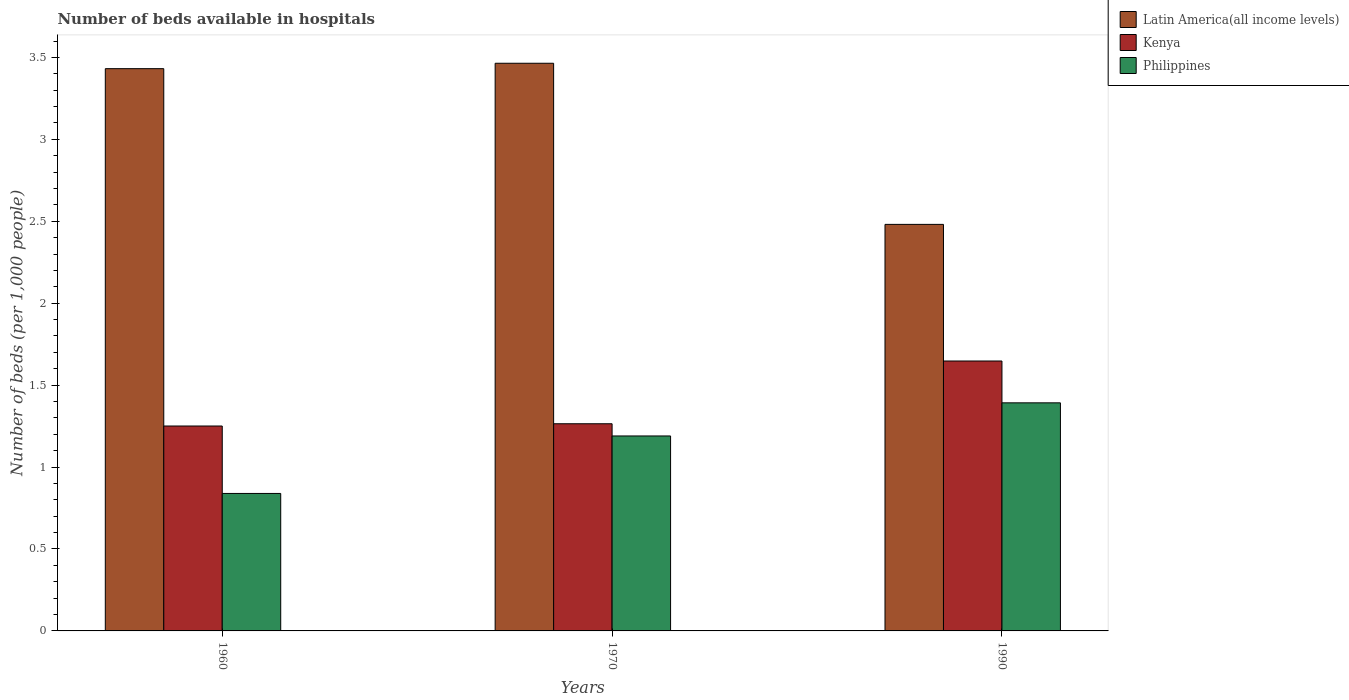How many different coloured bars are there?
Ensure brevity in your answer.  3. Are the number of bars on each tick of the X-axis equal?
Ensure brevity in your answer.  Yes. How many bars are there on the 2nd tick from the left?
Offer a very short reply. 3. How many bars are there on the 1st tick from the right?
Ensure brevity in your answer.  3. In how many cases, is the number of bars for a given year not equal to the number of legend labels?
Offer a terse response. 0. What is the number of beds in the hospiatls of in Latin America(all income levels) in 1990?
Offer a very short reply. 2.48. Across all years, what is the maximum number of beds in the hospiatls of in Latin America(all income levels)?
Your response must be concise. 3.46. Across all years, what is the minimum number of beds in the hospiatls of in Philippines?
Give a very brief answer. 0.84. In which year was the number of beds in the hospiatls of in Latin America(all income levels) minimum?
Keep it short and to the point. 1990. What is the total number of beds in the hospiatls of in Philippines in the graph?
Your answer should be compact. 3.42. What is the difference between the number of beds in the hospiatls of in Philippines in 1960 and that in 1990?
Keep it short and to the point. -0.55. What is the difference between the number of beds in the hospiatls of in Kenya in 1970 and the number of beds in the hospiatls of in Philippines in 1990?
Offer a terse response. -0.13. What is the average number of beds in the hospiatls of in Kenya per year?
Keep it short and to the point. 1.39. In the year 1990, what is the difference between the number of beds in the hospiatls of in Philippines and number of beds in the hospiatls of in Latin America(all income levels)?
Give a very brief answer. -1.09. What is the ratio of the number of beds in the hospiatls of in Philippines in 1960 to that in 1970?
Your answer should be very brief. 0.71. Is the difference between the number of beds in the hospiatls of in Philippines in 1960 and 1970 greater than the difference between the number of beds in the hospiatls of in Latin America(all income levels) in 1960 and 1970?
Your answer should be very brief. No. What is the difference between the highest and the second highest number of beds in the hospiatls of in Philippines?
Provide a short and direct response. 0.2. What is the difference between the highest and the lowest number of beds in the hospiatls of in Latin America(all income levels)?
Your answer should be very brief. 0.98. In how many years, is the number of beds in the hospiatls of in Kenya greater than the average number of beds in the hospiatls of in Kenya taken over all years?
Ensure brevity in your answer.  1. What does the 2nd bar from the left in 1990 represents?
Your answer should be very brief. Kenya. What does the 1st bar from the right in 1960 represents?
Give a very brief answer. Philippines. Is it the case that in every year, the sum of the number of beds in the hospiatls of in Latin America(all income levels) and number of beds in the hospiatls of in Philippines is greater than the number of beds in the hospiatls of in Kenya?
Ensure brevity in your answer.  Yes. Are all the bars in the graph horizontal?
Your answer should be compact. No. How many years are there in the graph?
Offer a terse response. 3. Are the values on the major ticks of Y-axis written in scientific E-notation?
Your response must be concise. No. Does the graph contain grids?
Provide a short and direct response. No. Where does the legend appear in the graph?
Offer a terse response. Top right. How are the legend labels stacked?
Your answer should be very brief. Vertical. What is the title of the graph?
Give a very brief answer. Number of beds available in hospitals. What is the label or title of the X-axis?
Your answer should be very brief. Years. What is the label or title of the Y-axis?
Offer a terse response. Number of beds (per 1,0 people). What is the Number of beds (per 1,000 people) in Latin America(all income levels) in 1960?
Keep it short and to the point. 3.43. What is the Number of beds (per 1,000 people) of Kenya in 1960?
Your answer should be very brief. 1.25. What is the Number of beds (per 1,000 people) of Philippines in 1960?
Provide a succinct answer. 0.84. What is the Number of beds (per 1,000 people) of Latin America(all income levels) in 1970?
Your response must be concise. 3.46. What is the Number of beds (per 1,000 people) in Kenya in 1970?
Your answer should be compact. 1.26. What is the Number of beds (per 1,000 people) of Philippines in 1970?
Your response must be concise. 1.19. What is the Number of beds (per 1,000 people) of Latin America(all income levels) in 1990?
Offer a very short reply. 2.48. What is the Number of beds (per 1,000 people) of Kenya in 1990?
Offer a terse response. 1.65. What is the Number of beds (per 1,000 people) in Philippines in 1990?
Offer a terse response. 1.39. Across all years, what is the maximum Number of beds (per 1,000 people) of Latin America(all income levels)?
Ensure brevity in your answer.  3.46. Across all years, what is the maximum Number of beds (per 1,000 people) of Kenya?
Offer a terse response. 1.65. Across all years, what is the maximum Number of beds (per 1,000 people) of Philippines?
Offer a very short reply. 1.39. Across all years, what is the minimum Number of beds (per 1,000 people) in Latin America(all income levels)?
Keep it short and to the point. 2.48. Across all years, what is the minimum Number of beds (per 1,000 people) in Kenya?
Provide a succinct answer. 1.25. Across all years, what is the minimum Number of beds (per 1,000 people) of Philippines?
Give a very brief answer. 0.84. What is the total Number of beds (per 1,000 people) in Latin America(all income levels) in the graph?
Your response must be concise. 9.38. What is the total Number of beds (per 1,000 people) of Kenya in the graph?
Your response must be concise. 4.16. What is the total Number of beds (per 1,000 people) in Philippines in the graph?
Offer a very short reply. 3.42. What is the difference between the Number of beds (per 1,000 people) of Latin America(all income levels) in 1960 and that in 1970?
Provide a succinct answer. -0.03. What is the difference between the Number of beds (per 1,000 people) in Kenya in 1960 and that in 1970?
Your answer should be very brief. -0.01. What is the difference between the Number of beds (per 1,000 people) in Philippines in 1960 and that in 1970?
Your answer should be compact. -0.35. What is the difference between the Number of beds (per 1,000 people) in Latin America(all income levels) in 1960 and that in 1990?
Your answer should be very brief. 0.95. What is the difference between the Number of beds (per 1,000 people) of Kenya in 1960 and that in 1990?
Offer a terse response. -0.4. What is the difference between the Number of beds (per 1,000 people) in Philippines in 1960 and that in 1990?
Give a very brief answer. -0.55. What is the difference between the Number of beds (per 1,000 people) in Latin America(all income levels) in 1970 and that in 1990?
Ensure brevity in your answer.  0.98. What is the difference between the Number of beds (per 1,000 people) in Kenya in 1970 and that in 1990?
Your response must be concise. -0.38. What is the difference between the Number of beds (per 1,000 people) of Philippines in 1970 and that in 1990?
Your answer should be compact. -0.2. What is the difference between the Number of beds (per 1,000 people) in Latin America(all income levels) in 1960 and the Number of beds (per 1,000 people) in Kenya in 1970?
Ensure brevity in your answer.  2.17. What is the difference between the Number of beds (per 1,000 people) of Latin America(all income levels) in 1960 and the Number of beds (per 1,000 people) of Philippines in 1970?
Make the answer very short. 2.24. What is the difference between the Number of beds (per 1,000 people) in Kenya in 1960 and the Number of beds (per 1,000 people) in Philippines in 1970?
Offer a terse response. 0.06. What is the difference between the Number of beds (per 1,000 people) in Latin America(all income levels) in 1960 and the Number of beds (per 1,000 people) in Kenya in 1990?
Offer a terse response. 1.78. What is the difference between the Number of beds (per 1,000 people) of Latin America(all income levels) in 1960 and the Number of beds (per 1,000 people) of Philippines in 1990?
Make the answer very short. 2.04. What is the difference between the Number of beds (per 1,000 people) of Kenya in 1960 and the Number of beds (per 1,000 people) of Philippines in 1990?
Give a very brief answer. -0.14. What is the difference between the Number of beds (per 1,000 people) in Latin America(all income levels) in 1970 and the Number of beds (per 1,000 people) in Kenya in 1990?
Provide a short and direct response. 1.82. What is the difference between the Number of beds (per 1,000 people) of Latin America(all income levels) in 1970 and the Number of beds (per 1,000 people) of Philippines in 1990?
Give a very brief answer. 2.07. What is the difference between the Number of beds (per 1,000 people) in Kenya in 1970 and the Number of beds (per 1,000 people) in Philippines in 1990?
Offer a terse response. -0.13. What is the average Number of beds (per 1,000 people) in Latin America(all income levels) per year?
Ensure brevity in your answer.  3.13. What is the average Number of beds (per 1,000 people) of Kenya per year?
Your response must be concise. 1.39. What is the average Number of beds (per 1,000 people) in Philippines per year?
Give a very brief answer. 1.14. In the year 1960, what is the difference between the Number of beds (per 1,000 people) of Latin America(all income levels) and Number of beds (per 1,000 people) of Kenya?
Your answer should be very brief. 2.18. In the year 1960, what is the difference between the Number of beds (per 1,000 people) of Latin America(all income levels) and Number of beds (per 1,000 people) of Philippines?
Make the answer very short. 2.59. In the year 1960, what is the difference between the Number of beds (per 1,000 people) in Kenya and Number of beds (per 1,000 people) in Philippines?
Provide a succinct answer. 0.41. In the year 1970, what is the difference between the Number of beds (per 1,000 people) of Latin America(all income levels) and Number of beds (per 1,000 people) of Kenya?
Your answer should be compact. 2.2. In the year 1970, what is the difference between the Number of beds (per 1,000 people) of Latin America(all income levels) and Number of beds (per 1,000 people) of Philippines?
Keep it short and to the point. 2.27. In the year 1970, what is the difference between the Number of beds (per 1,000 people) of Kenya and Number of beds (per 1,000 people) of Philippines?
Ensure brevity in your answer.  0.07. In the year 1990, what is the difference between the Number of beds (per 1,000 people) in Latin America(all income levels) and Number of beds (per 1,000 people) in Kenya?
Offer a terse response. 0.83. In the year 1990, what is the difference between the Number of beds (per 1,000 people) in Latin America(all income levels) and Number of beds (per 1,000 people) in Philippines?
Your response must be concise. 1.09. In the year 1990, what is the difference between the Number of beds (per 1,000 people) of Kenya and Number of beds (per 1,000 people) of Philippines?
Your answer should be very brief. 0.26. What is the ratio of the Number of beds (per 1,000 people) of Philippines in 1960 to that in 1970?
Offer a terse response. 0.71. What is the ratio of the Number of beds (per 1,000 people) in Latin America(all income levels) in 1960 to that in 1990?
Provide a short and direct response. 1.38. What is the ratio of the Number of beds (per 1,000 people) of Kenya in 1960 to that in 1990?
Keep it short and to the point. 0.76. What is the ratio of the Number of beds (per 1,000 people) in Philippines in 1960 to that in 1990?
Your answer should be very brief. 0.6. What is the ratio of the Number of beds (per 1,000 people) in Latin America(all income levels) in 1970 to that in 1990?
Your answer should be compact. 1.4. What is the ratio of the Number of beds (per 1,000 people) in Kenya in 1970 to that in 1990?
Make the answer very short. 0.77. What is the ratio of the Number of beds (per 1,000 people) in Philippines in 1970 to that in 1990?
Provide a short and direct response. 0.85. What is the difference between the highest and the second highest Number of beds (per 1,000 people) of Latin America(all income levels)?
Offer a very short reply. 0.03. What is the difference between the highest and the second highest Number of beds (per 1,000 people) in Kenya?
Offer a terse response. 0.38. What is the difference between the highest and the second highest Number of beds (per 1,000 people) in Philippines?
Ensure brevity in your answer.  0.2. What is the difference between the highest and the lowest Number of beds (per 1,000 people) of Latin America(all income levels)?
Your response must be concise. 0.98. What is the difference between the highest and the lowest Number of beds (per 1,000 people) of Kenya?
Provide a succinct answer. 0.4. What is the difference between the highest and the lowest Number of beds (per 1,000 people) in Philippines?
Provide a succinct answer. 0.55. 